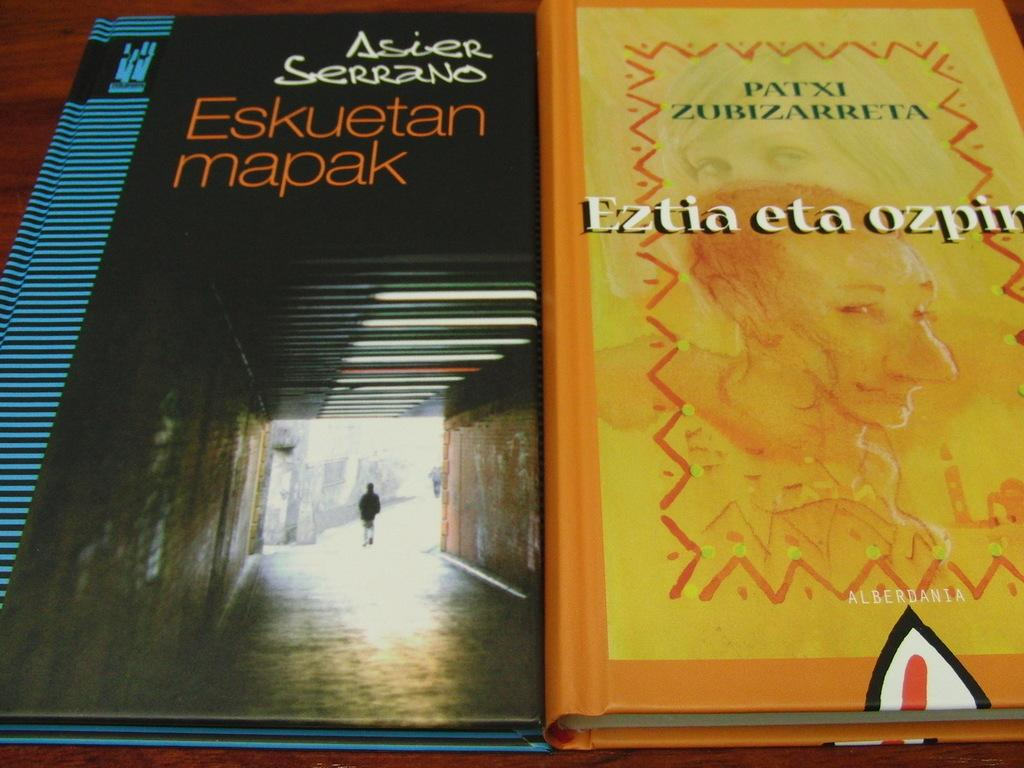<image>
Offer a succinct explanation of the picture presented. Two books sit side by side with one written by Patxi Zubizarreta. 